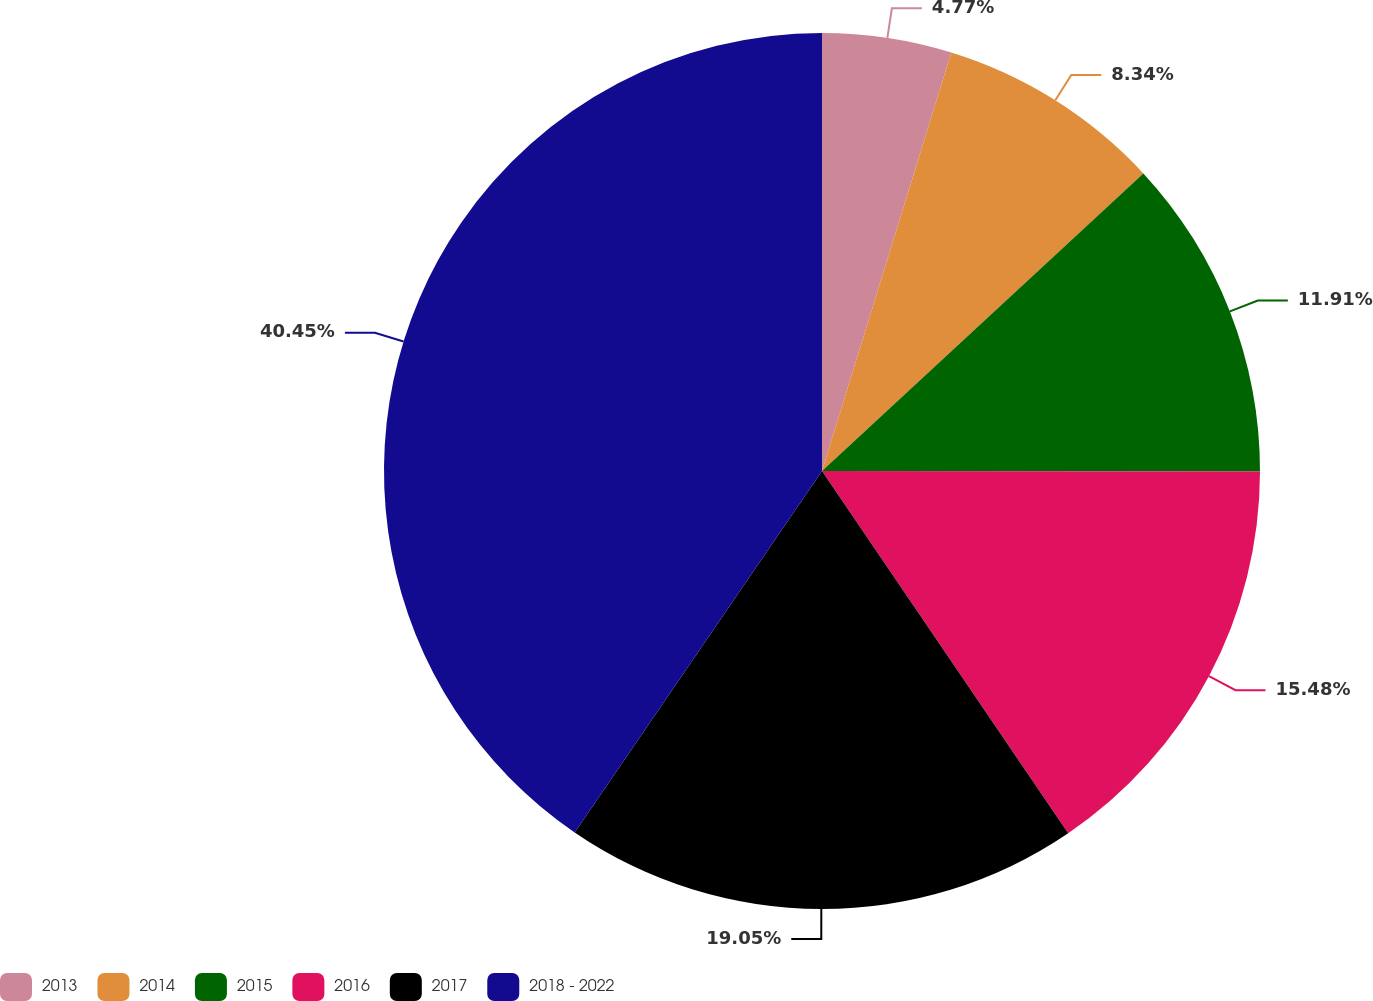Convert chart. <chart><loc_0><loc_0><loc_500><loc_500><pie_chart><fcel>2013<fcel>2014<fcel>2015<fcel>2016<fcel>2017<fcel>2018 - 2022<nl><fcel>4.77%<fcel>8.34%<fcel>11.91%<fcel>15.48%<fcel>19.05%<fcel>40.45%<nl></chart> 